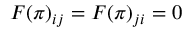<formula> <loc_0><loc_0><loc_500><loc_500>F ( { \boldsymbol \pi } ) _ { i j } = F ( { \boldsymbol \pi } ) _ { j i } = 0</formula> 